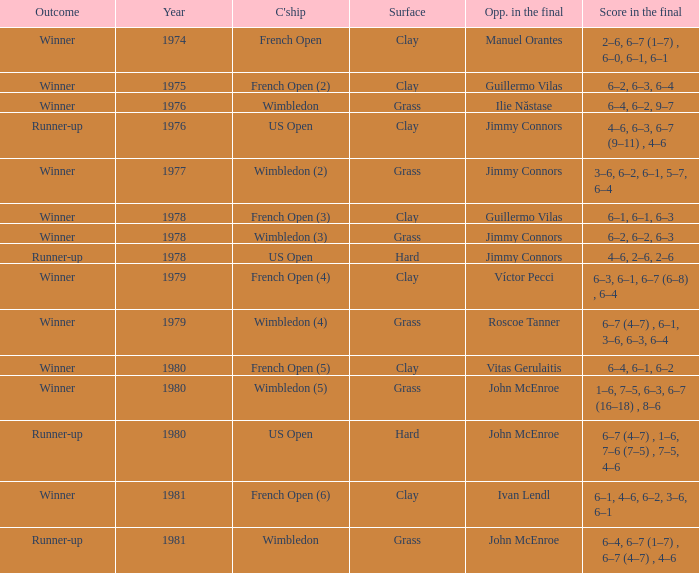What is every score in the final for opponent in final John Mcenroe at US Open? 6–7 (4–7) , 1–6, 7–6 (7–5) , 7–5, 4–6. 